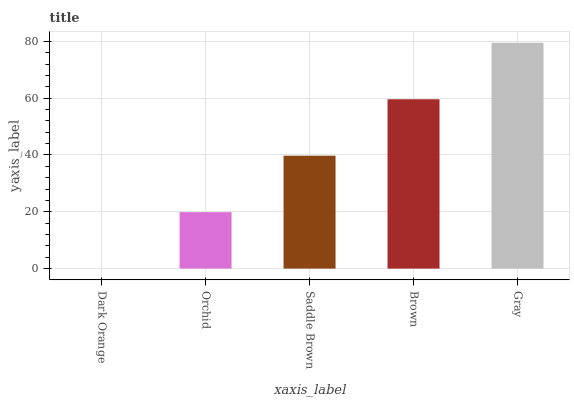Is Dark Orange the minimum?
Answer yes or no. Yes. Is Gray the maximum?
Answer yes or no. Yes. Is Orchid the minimum?
Answer yes or no. No. Is Orchid the maximum?
Answer yes or no. No. Is Orchid greater than Dark Orange?
Answer yes or no. Yes. Is Dark Orange less than Orchid?
Answer yes or no. Yes. Is Dark Orange greater than Orchid?
Answer yes or no. No. Is Orchid less than Dark Orange?
Answer yes or no. No. Is Saddle Brown the high median?
Answer yes or no. Yes. Is Saddle Brown the low median?
Answer yes or no. Yes. Is Brown the high median?
Answer yes or no. No. Is Brown the low median?
Answer yes or no. No. 